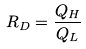<formula> <loc_0><loc_0><loc_500><loc_500>R _ { D } = \frac { Q _ { H } } { Q _ { L } }</formula> 